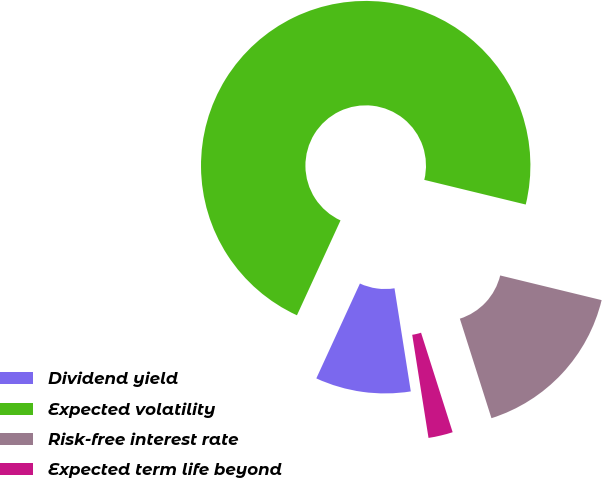Convert chart to OTSL. <chart><loc_0><loc_0><loc_500><loc_500><pie_chart><fcel>Dividend yield<fcel>Expected volatility<fcel>Risk-free interest rate<fcel>Expected term life beyond<nl><fcel>9.35%<fcel>71.94%<fcel>16.31%<fcel>2.4%<nl></chart> 